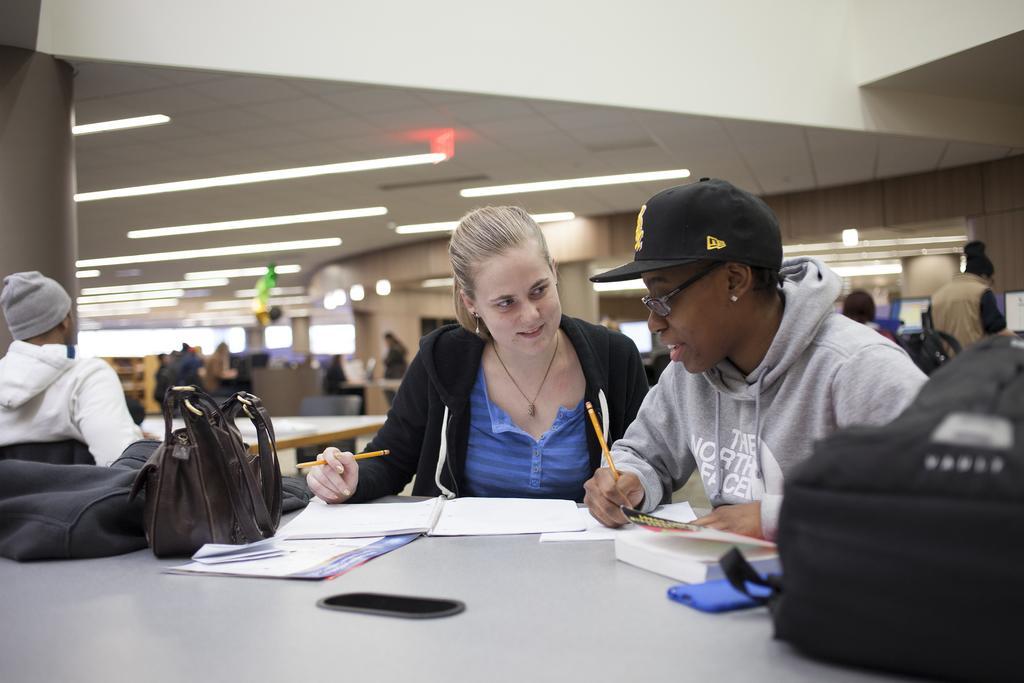In one or two sentences, can you explain what this image depicts? In this image we can see some group of persons in the foreground of the image there are two persons sitting on chairs around table holding pencils in their hands there are some books, bags, mobile phone on table and in the background of the image there is wall, lights and some other tables. 